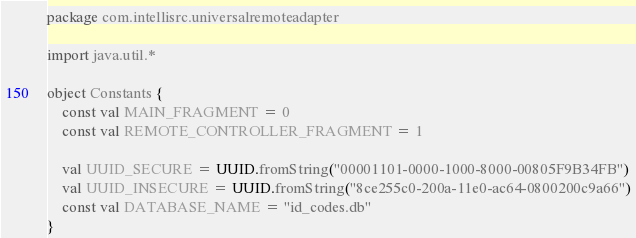<code> <loc_0><loc_0><loc_500><loc_500><_Kotlin_>package com.intellisrc.universalremoteadapter

import java.util.*

object Constants {
    const val MAIN_FRAGMENT = 0
    const val REMOTE_CONTROLLER_FRAGMENT = 1

    val UUID_SECURE = UUID.fromString("00001101-0000-1000-8000-00805F9B34FB")
    val UUID_INSECURE = UUID.fromString("8ce255c0-200a-11e0-ac64-0800200c9a66")
    const val DATABASE_NAME = "id_codes.db"
}</code> 